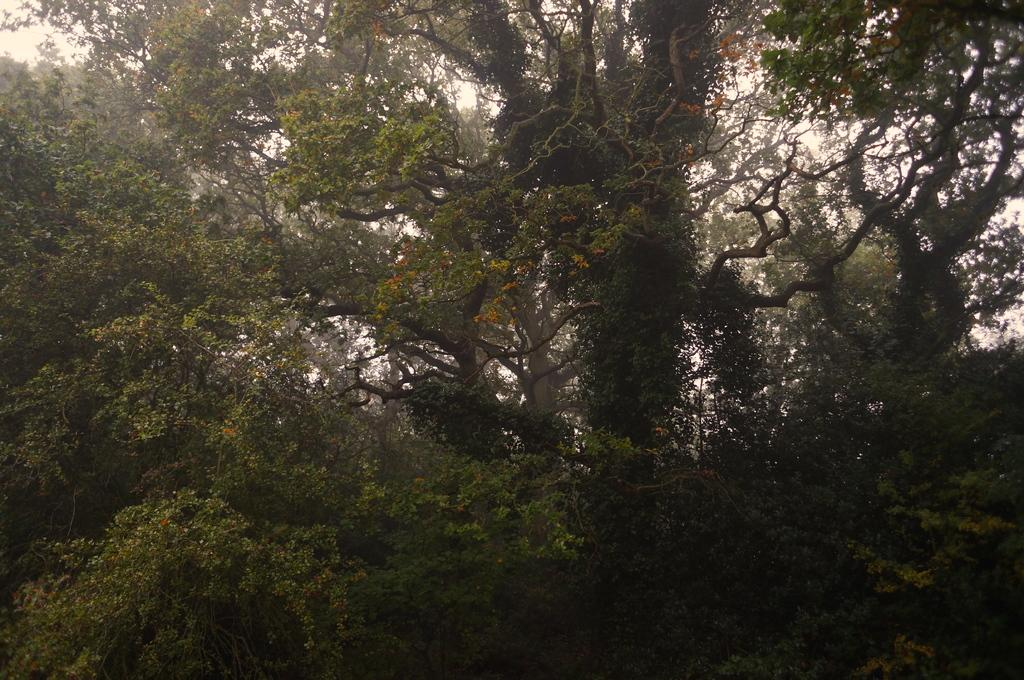What type of vegetation can be seen in the image? There are trees in the image. What part of the natural environment is visible in the image? The sky is visible in the image. How many boats are present in the image? There are no boats visible in the image; it only features trees and the sky. What type of industry can be seen in the image? There is no industry present in the image; it only features trees and the sky. 